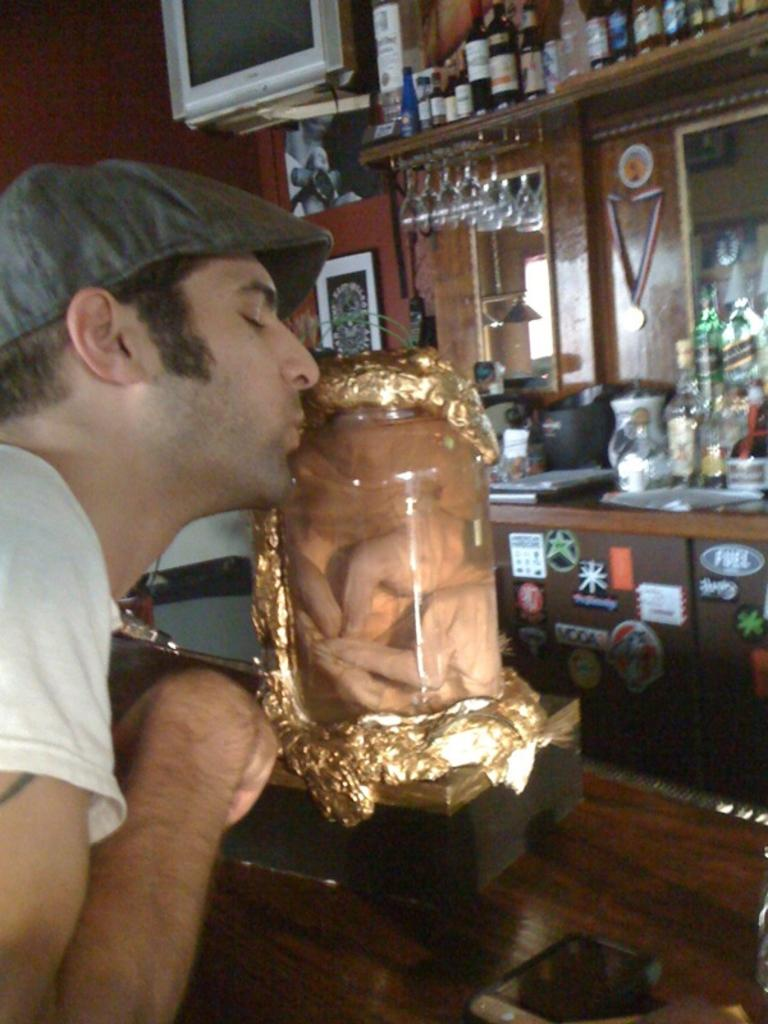What is the person in the image wearing on their head? The person is wearing a hat in the image. What type of object can be seen in the image that is made of glass? There is a glass object in the image. What can be seen in the background of the image that is related to serving drinks? There are bottles and glasses in the background of the image. What type of electronic device is visible in the background of the image? There is a TV in the background of the image. What other objects can be seen on the table in the background of the image? There are there any other objects on the table in the background of the image? What type of drug is being sold in the image? There is no indication of any drug being sold or present in the image. 